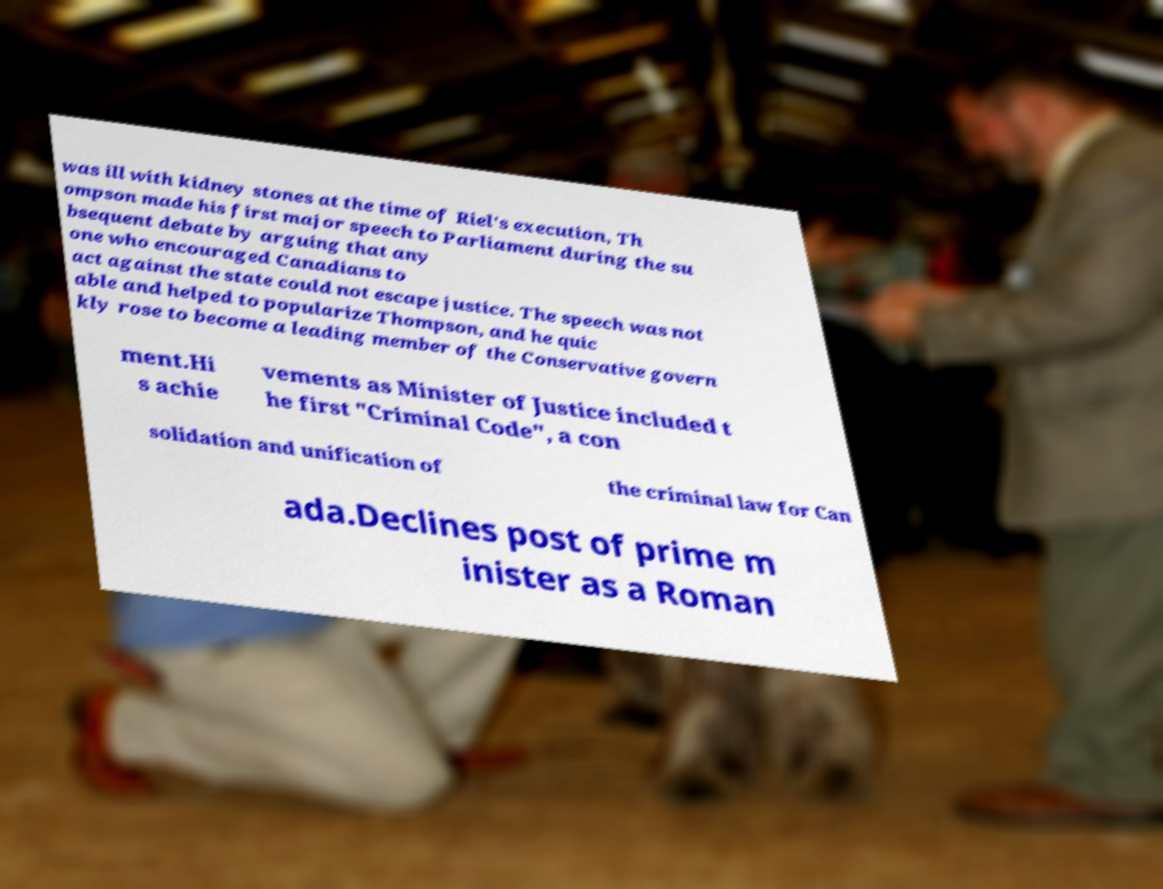Could you extract and type out the text from this image? was ill with kidney stones at the time of Riel's execution, Th ompson made his first major speech to Parliament during the su bsequent debate by arguing that any one who encouraged Canadians to act against the state could not escape justice. The speech was not able and helped to popularize Thompson, and he quic kly rose to become a leading member of the Conservative govern ment.Hi s achie vements as Minister of Justice included t he first "Criminal Code", a con solidation and unification of the criminal law for Can ada.Declines post of prime m inister as a Roman 